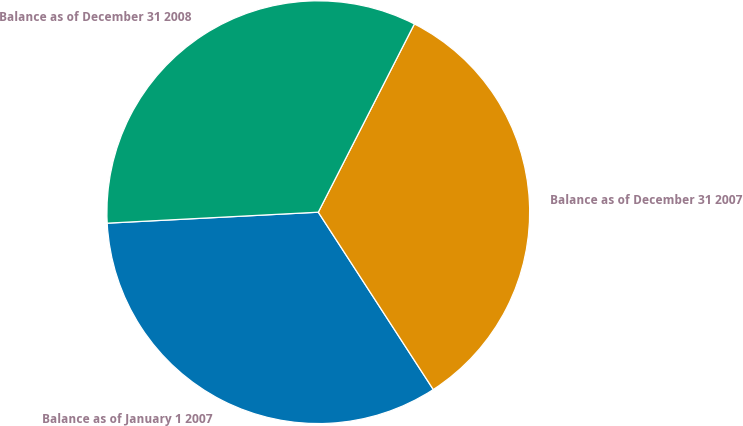<chart> <loc_0><loc_0><loc_500><loc_500><pie_chart><fcel>Balance as of January 1 2007<fcel>Balance as of December 31 2007<fcel>Balance as of December 31 2008<nl><fcel>33.33%<fcel>33.33%<fcel>33.34%<nl></chart> 